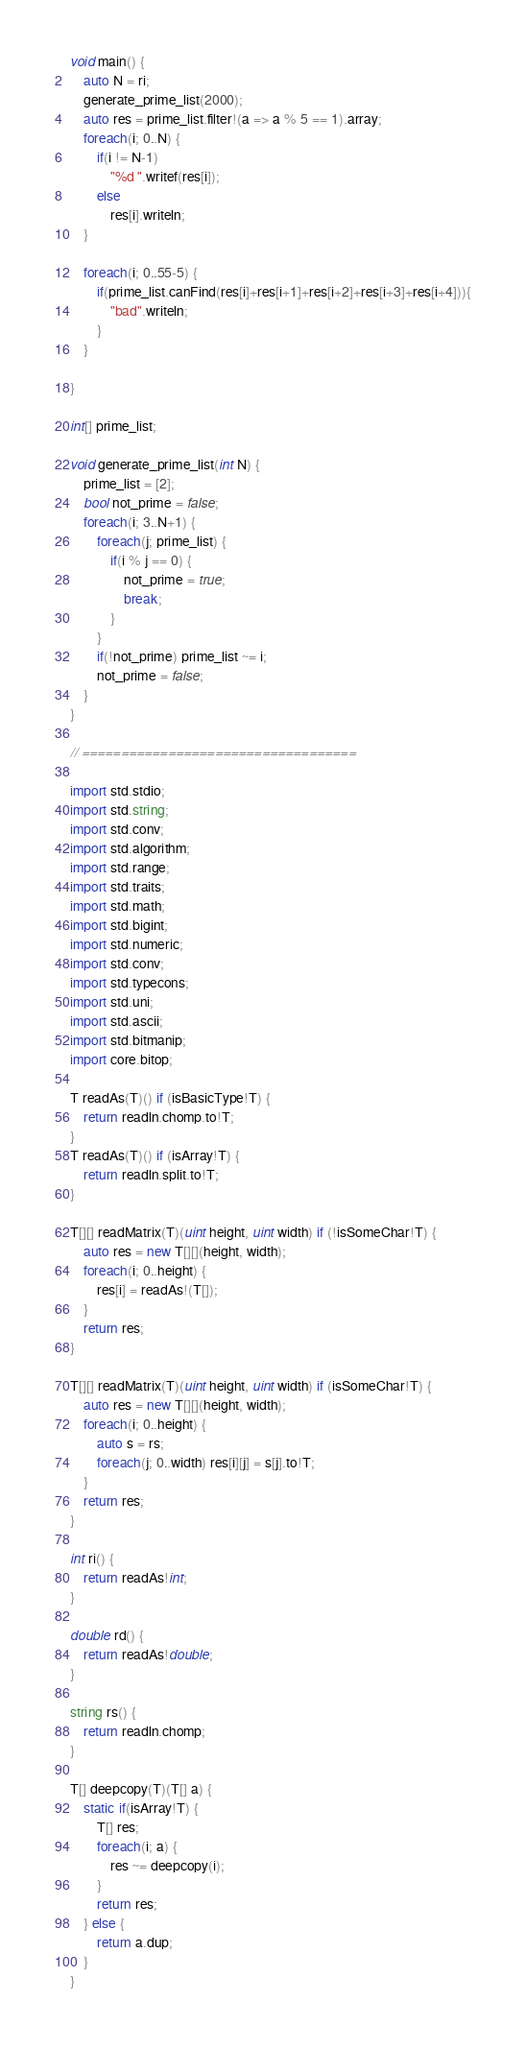<code> <loc_0><loc_0><loc_500><loc_500><_D_>void main() {
	auto N = ri;
	generate_prime_list(2000);
	auto res = prime_list.filter!(a => a % 5 == 1).array;
	foreach(i; 0..N) {
		if(i != N-1)
			"%d ".writef(res[i]);
		else
			res[i].writeln;
	}
	
	foreach(i; 0..55-5) {
		if(prime_list.canFind(res[i]+res[i+1]+res[i+2]+res[i+3]+res[i+4])){
			"bad".writeln;
		}
	}
	
}

int[] prime_list;

void generate_prime_list(int N) {
	prime_list = [2];
	bool not_prime = false;
	foreach(i; 3..N+1) {
		foreach(j; prime_list) {
			if(i % j == 0) {
				not_prime = true;
				break;
			}
		}
		if(!not_prime) prime_list ~= i;
		not_prime = false;
	}
}

// ===================================

import std.stdio;
import std.string;
import std.conv;
import std.algorithm;
import std.range;
import std.traits;
import std.math;
import std.bigint;
import std.numeric;
import std.conv;
import std.typecons;
import std.uni;
import std.ascii;
import std.bitmanip;
import core.bitop;

T readAs(T)() if (isBasicType!T) {
	return readln.chomp.to!T;
}
T readAs(T)() if (isArray!T) {
	return readln.split.to!T;
}

T[][] readMatrix(T)(uint height, uint width) if (!isSomeChar!T) {
	auto res = new T[][](height, width);
	foreach(i; 0..height) {
		res[i] = readAs!(T[]);
	}
	return res;
}

T[][] readMatrix(T)(uint height, uint width) if (isSomeChar!T) {
	auto res = new T[][](height, width);
	foreach(i; 0..height) {
		auto s = rs;
		foreach(j; 0..width) res[i][j] = s[j].to!T;
	}
	return res;
}

int ri() {
	return readAs!int;
}

double rd() {
	return readAs!double;
}

string rs() {
	return readln.chomp;
}

T[] deepcopy(T)(T[] a) {
	static if(isArray!T) {
		T[] res;
		foreach(i; a) {
			res ~= deepcopy(i);
		}
		return res;
	} else {
		return a.dup;
	}
}</code> 